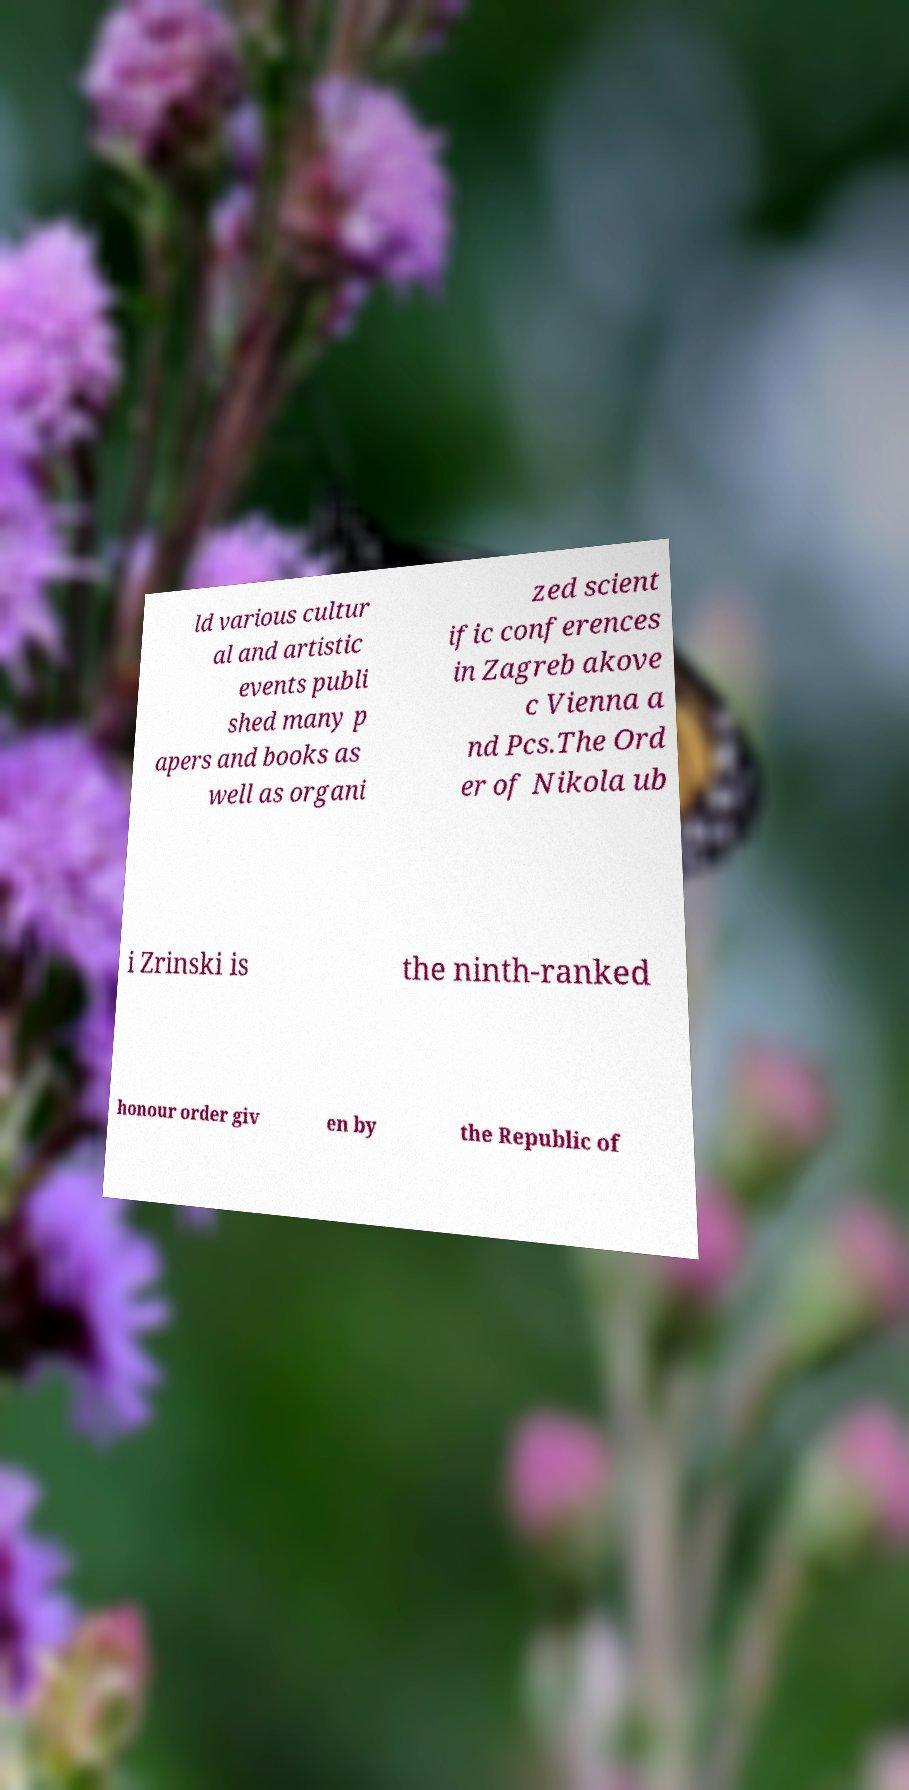I need the written content from this picture converted into text. Can you do that? ld various cultur al and artistic events publi shed many p apers and books as well as organi zed scient ific conferences in Zagreb akove c Vienna a nd Pcs.The Ord er of Nikola ub i Zrinski is the ninth-ranked honour order giv en by the Republic of 